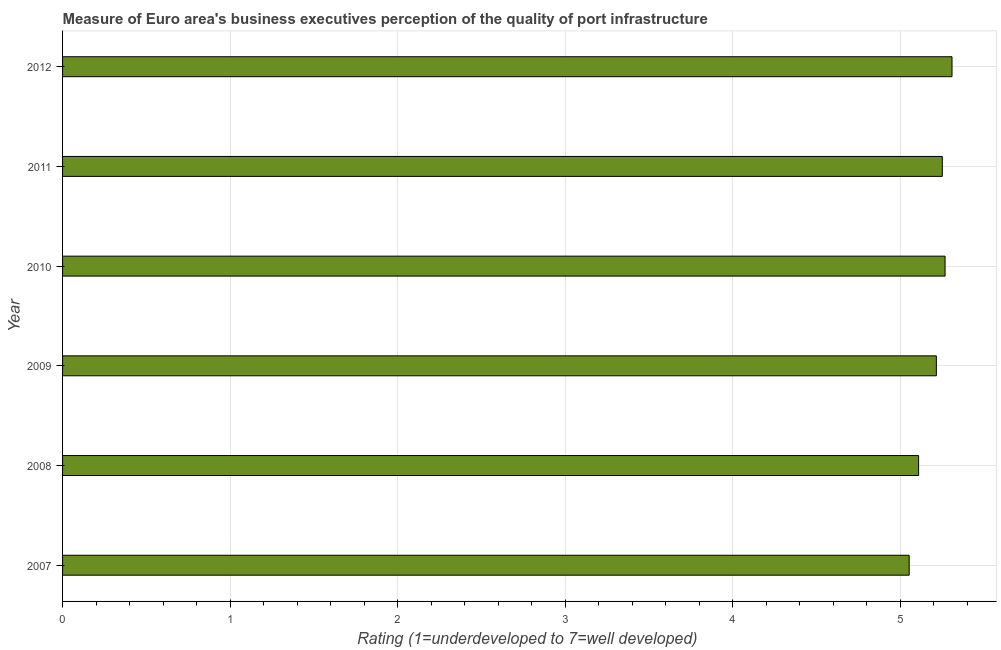Does the graph contain any zero values?
Offer a terse response. No. What is the title of the graph?
Offer a terse response. Measure of Euro area's business executives perception of the quality of port infrastructure. What is the label or title of the X-axis?
Offer a very short reply. Rating (1=underdeveloped to 7=well developed) . What is the rating measuring quality of port infrastructure in 2012?
Provide a short and direct response. 5.31. Across all years, what is the maximum rating measuring quality of port infrastructure?
Offer a very short reply. 5.31. Across all years, what is the minimum rating measuring quality of port infrastructure?
Provide a short and direct response. 5.05. In which year was the rating measuring quality of port infrastructure maximum?
Give a very brief answer. 2012. In which year was the rating measuring quality of port infrastructure minimum?
Your answer should be compact. 2007. What is the sum of the rating measuring quality of port infrastructure?
Keep it short and to the point. 31.21. What is the difference between the rating measuring quality of port infrastructure in 2008 and 2009?
Provide a succinct answer. -0.11. What is the average rating measuring quality of port infrastructure per year?
Provide a short and direct response. 5.2. What is the median rating measuring quality of port infrastructure?
Keep it short and to the point. 5.23. What is the ratio of the rating measuring quality of port infrastructure in 2007 to that in 2011?
Make the answer very short. 0.96. Is the difference between the rating measuring quality of port infrastructure in 2011 and 2012 greater than the difference between any two years?
Your response must be concise. No. What is the difference between the highest and the second highest rating measuring quality of port infrastructure?
Your answer should be very brief. 0.04. What is the difference between the highest and the lowest rating measuring quality of port infrastructure?
Your response must be concise. 0.26. In how many years, is the rating measuring quality of port infrastructure greater than the average rating measuring quality of port infrastructure taken over all years?
Keep it short and to the point. 4. How many years are there in the graph?
Offer a terse response. 6. Are the values on the major ticks of X-axis written in scientific E-notation?
Keep it short and to the point. No. What is the Rating (1=underdeveloped to 7=well developed)  in 2007?
Ensure brevity in your answer.  5.05. What is the Rating (1=underdeveloped to 7=well developed)  of 2008?
Provide a succinct answer. 5.11. What is the Rating (1=underdeveloped to 7=well developed)  in 2009?
Offer a very short reply. 5.22. What is the Rating (1=underdeveloped to 7=well developed)  of 2010?
Your answer should be compact. 5.27. What is the Rating (1=underdeveloped to 7=well developed)  of 2011?
Your answer should be compact. 5.25. What is the Rating (1=underdeveloped to 7=well developed)  of 2012?
Give a very brief answer. 5.31. What is the difference between the Rating (1=underdeveloped to 7=well developed)  in 2007 and 2008?
Give a very brief answer. -0.06. What is the difference between the Rating (1=underdeveloped to 7=well developed)  in 2007 and 2009?
Your answer should be very brief. -0.16. What is the difference between the Rating (1=underdeveloped to 7=well developed)  in 2007 and 2010?
Your answer should be compact. -0.21. What is the difference between the Rating (1=underdeveloped to 7=well developed)  in 2007 and 2011?
Keep it short and to the point. -0.2. What is the difference between the Rating (1=underdeveloped to 7=well developed)  in 2007 and 2012?
Offer a terse response. -0.26. What is the difference between the Rating (1=underdeveloped to 7=well developed)  in 2008 and 2009?
Your response must be concise. -0.11. What is the difference between the Rating (1=underdeveloped to 7=well developed)  in 2008 and 2010?
Offer a terse response. -0.16. What is the difference between the Rating (1=underdeveloped to 7=well developed)  in 2008 and 2011?
Offer a very short reply. -0.14. What is the difference between the Rating (1=underdeveloped to 7=well developed)  in 2008 and 2012?
Your response must be concise. -0.2. What is the difference between the Rating (1=underdeveloped to 7=well developed)  in 2009 and 2010?
Make the answer very short. -0.05. What is the difference between the Rating (1=underdeveloped to 7=well developed)  in 2009 and 2011?
Keep it short and to the point. -0.04. What is the difference between the Rating (1=underdeveloped to 7=well developed)  in 2009 and 2012?
Keep it short and to the point. -0.09. What is the difference between the Rating (1=underdeveloped to 7=well developed)  in 2010 and 2011?
Offer a terse response. 0.02. What is the difference between the Rating (1=underdeveloped to 7=well developed)  in 2010 and 2012?
Your answer should be compact. -0.04. What is the difference between the Rating (1=underdeveloped to 7=well developed)  in 2011 and 2012?
Your answer should be compact. -0.06. What is the ratio of the Rating (1=underdeveloped to 7=well developed)  in 2007 to that in 2010?
Give a very brief answer. 0.96. What is the ratio of the Rating (1=underdeveloped to 7=well developed)  in 2007 to that in 2011?
Keep it short and to the point. 0.96. What is the ratio of the Rating (1=underdeveloped to 7=well developed)  in 2007 to that in 2012?
Your response must be concise. 0.95. What is the ratio of the Rating (1=underdeveloped to 7=well developed)  in 2008 to that in 2009?
Offer a very short reply. 0.98. What is the ratio of the Rating (1=underdeveloped to 7=well developed)  in 2009 to that in 2010?
Offer a terse response. 0.99. What is the ratio of the Rating (1=underdeveloped to 7=well developed)  in 2009 to that in 2011?
Ensure brevity in your answer.  0.99. What is the ratio of the Rating (1=underdeveloped to 7=well developed)  in 2009 to that in 2012?
Give a very brief answer. 0.98. What is the ratio of the Rating (1=underdeveloped to 7=well developed)  in 2010 to that in 2012?
Give a very brief answer. 0.99. What is the ratio of the Rating (1=underdeveloped to 7=well developed)  in 2011 to that in 2012?
Your response must be concise. 0.99. 